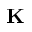Convert formula to latex. <formula><loc_0><loc_0><loc_500><loc_500>K</formula> 